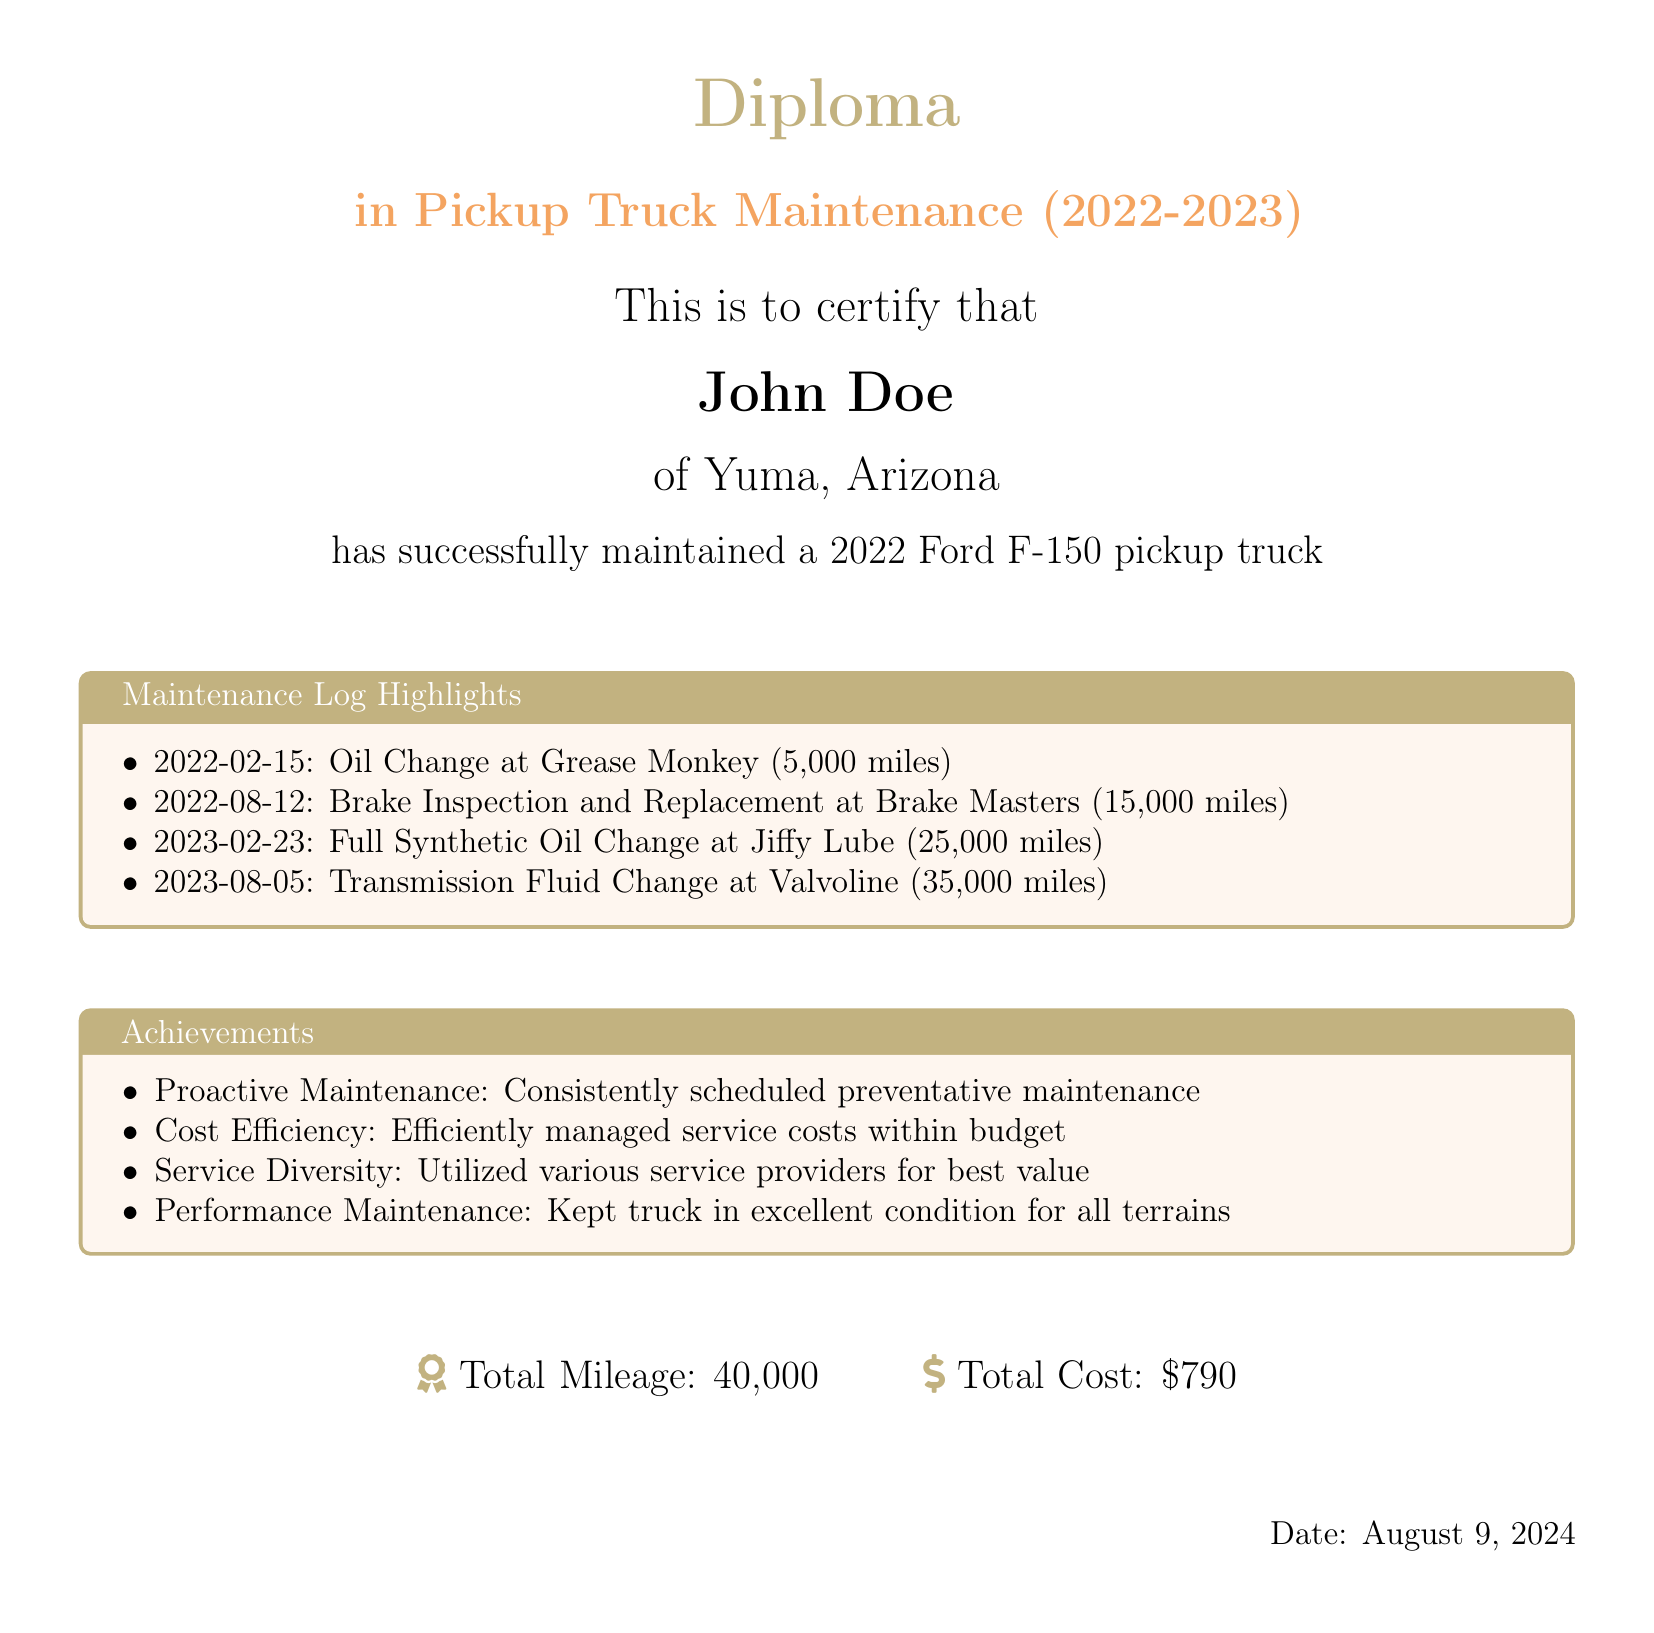what is the total mileage recorded? The total mileage is stated at the bottom of the document.
Answer: 40,000 who is the individual named on the diploma? The diploma certifies that John Doe completed the maintenance.
Answer: John Doe what is the total cost of maintenance services? The total cost is listed in the achievement section at the bottom of the document.
Answer: $790 which service was performed on August 12, 2022? The document highlights that a brake inspection and replacement occurred on this date.
Answer: Brake Inspection and Replacement what kind of maintenance service was done on February 23, 2023? The maintenance log indicates a full synthetic oil change on this date.
Answer: Full Synthetic Oil Change how many service providers were utilized for maintenance? The achievements section mentions utilizing various service providers for best value.
Answer: Various Service Providers which date marks the first recorded service? The first recorded service in the log is on February 15, 2022.
Answer: February 15, 2022 what type of vehicle is mentioned in the diploma? The diploma specifies a Ford F-150 pickup truck.
Answer: Ford F-150 what is the specific title of the diploma? The title of the diploma indicates the certification in pickup truck maintenance for the given years.
Answer: Diploma in Pickup Truck Maintenance (2022-2023) 